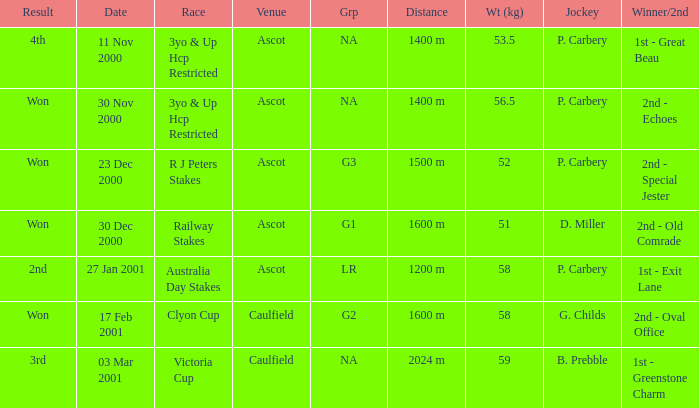What was the result for the railway stakes race? Won. 